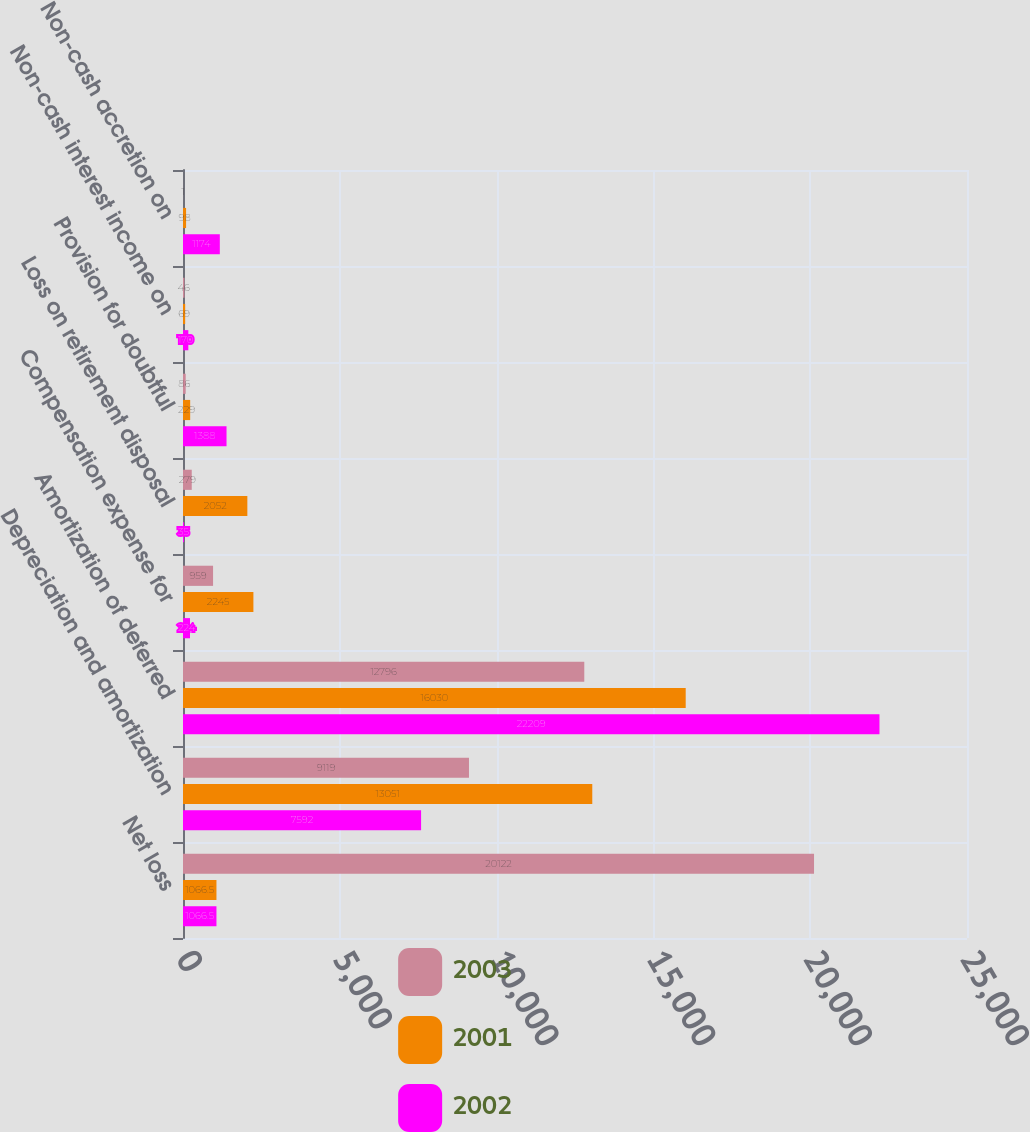<chart> <loc_0><loc_0><loc_500><loc_500><stacked_bar_chart><ecel><fcel>Net loss<fcel>Depreciation and amortization<fcel>Amortization of deferred<fcel>Compensation expense for<fcel>Loss on retirement disposal<fcel>Provision for doubtful<fcel>Non-cash interest income on<fcel>Non-cash accretion on<nl><fcel>2003<fcel>20122<fcel>9119<fcel>12796<fcel>959<fcel>279<fcel>86<fcel>46<fcel>1<nl><fcel>2001<fcel>1066.5<fcel>13051<fcel>16030<fcel>2245<fcel>2052<fcel>229<fcel>69<fcel>98<nl><fcel>2002<fcel>1066.5<fcel>7592<fcel>22209<fcel>224<fcel>35<fcel>1388<fcel>170<fcel>1174<nl></chart> 